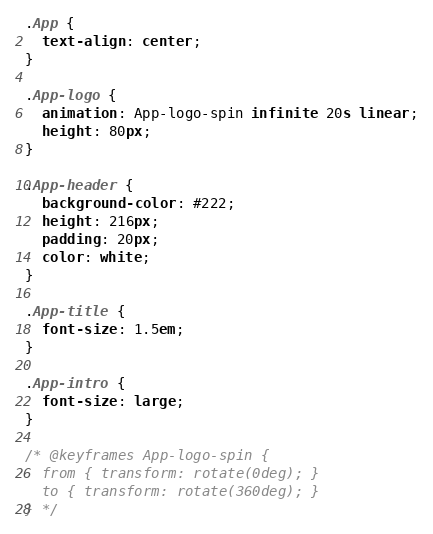Convert code to text. <code><loc_0><loc_0><loc_500><loc_500><_CSS_>.App {
  text-align: center;
}

.App-logo {
  animation: App-logo-spin infinite 20s linear;
  height: 80px;
}

.App-header {
  background-color: #222;
  height: 216px;
  padding: 20px;
  color: white;
}

.App-title {
  font-size: 1.5em;
}

.App-intro {
  font-size: large;
}

/* @keyframes App-logo-spin {
  from { transform: rotate(0deg); }
  to { transform: rotate(360deg); }
} */
</code> 